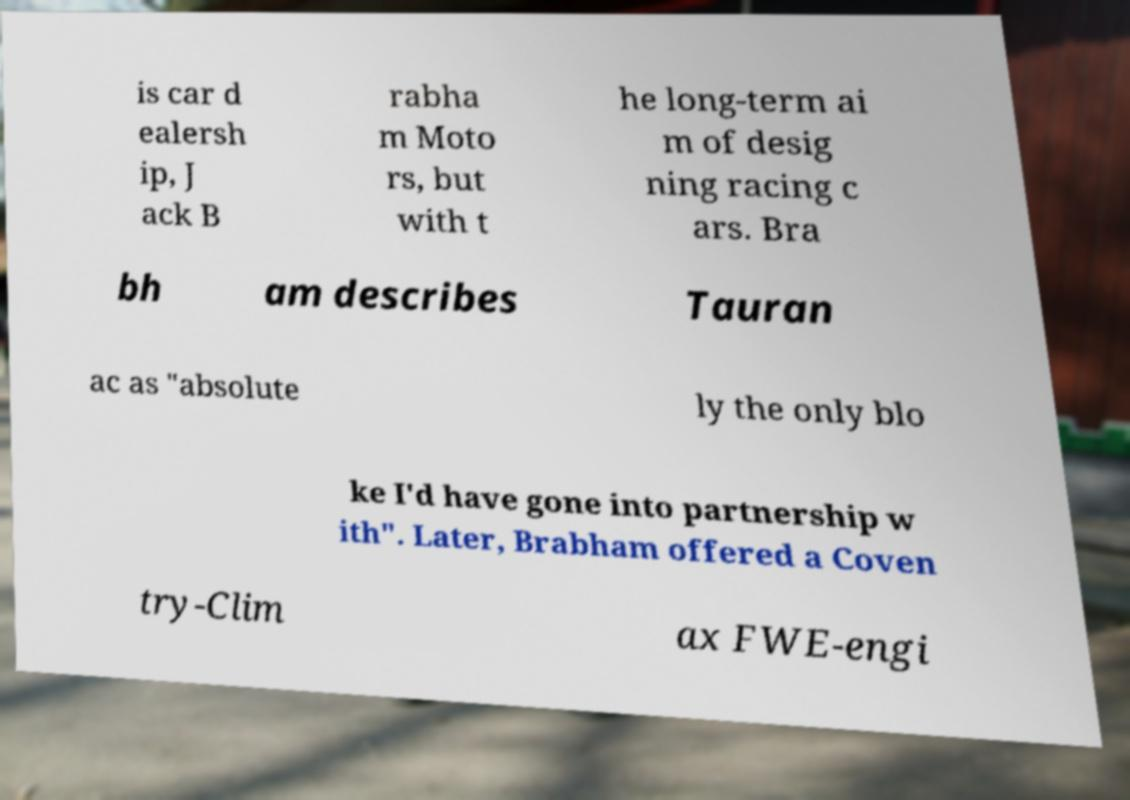Please read and relay the text visible in this image. What does it say? is car d ealersh ip, J ack B rabha m Moto rs, but with t he long-term ai m of desig ning racing c ars. Bra bh am describes Tauran ac as "absolute ly the only blo ke I'd have gone into partnership w ith". Later, Brabham offered a Coven try-Clim ax FWE-engi 